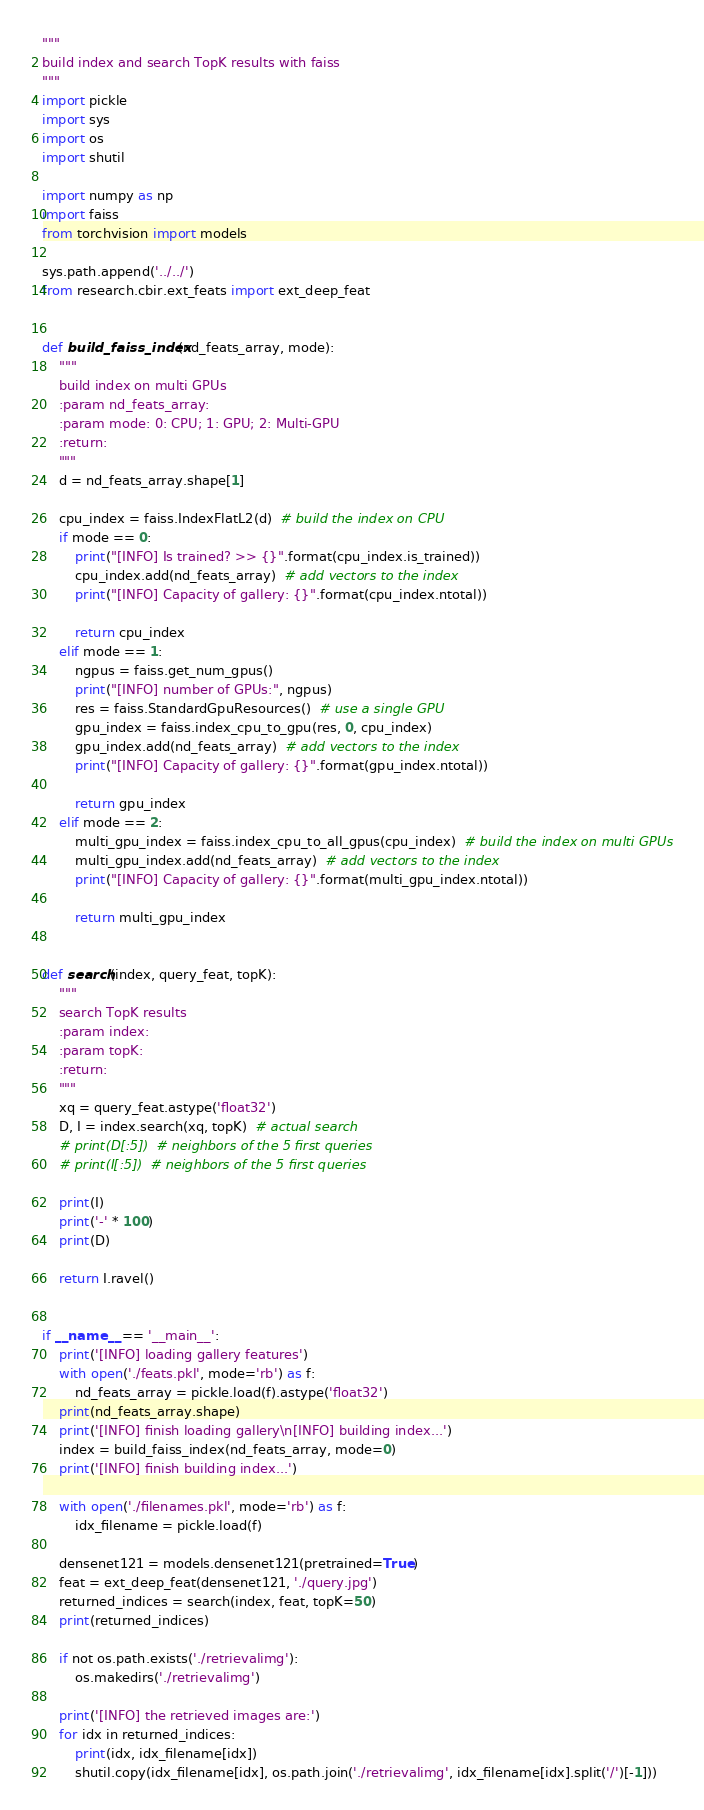Convert code to text. <code><loc_0><loc_0><loc_500><loc_500><_Python_>"""
build index and search TopK results with faiss
"""
import pickle
import sys
import os
import shutil

import numpy as np
import faiss
from torchvision import models

sys.path.append('../../')
from research.cbir.ext_feats import ext_deep_feat


def build_faiss_index(nd_feats_array, mode):
    """
    build index on multi GPUs
    :param nd_feats_array:
    :param mode: 0: CPU; 1: GPU; 2: Multi-GPU
    :return:
    """
    d = nd_feats_array.shape[1]

    cpu_index = faiss.IndexFlatL2(d)  # build the index on CPU
    if mode == 0:
        print("[INFO] Is trained? >> {}".format(cpu_index.is_trained))
        cpu_index.add(nd_feats_array)  # add vectors to the index
        print("[INFO] Capacity of gallery: {}".format(cpu_index.ntotal))

        return cpu_index
    elif mode == 1:
        ngpus = faiss.get_num_gpus()
        print("[INFO] number of GPUs:", ngpus)
        res = faiss.StandardGpuResources()  # use a single GPU
        gpu_index = faiss.index_cpu_to_gpu(res, 0, cpu_index)
        gpu_index.add(nd_feats_array)  # add vectors to the index
        print("[INFO] Capacity of gallery: {}".format(gpu_index.ntotal))

        return gpu_index
    elif mode == 2:
        multi_gpu_index = faiss.index_cpu_to_all_gpus(cpu_index)  # build the index on multi GPUs
        multi_gpu_index.add(nd_feats_array)  # add vectors to the index
        print("[INFO] Capacity of gallery: {}".format(multi_gpu_index.ntotal))

        return multi_gpu_index


def search(index, query_feat, topK):
    """
    search TopK results
    :param index:
    :param topK:
    :return:
    """
    xq = query_feat.astype('float32')
    D, I = index.search(xq, topK)  # actual search
    # print(D[:5])  # neighbors of the 5 first queries
    # print(I[:5])  # neighbors of the 5 first queries

    print(I)
    print('-' * 100)
    print(D)

    return I.ravel()


if __name__ == '__main__':
    print('[INFO] loading gallery features')
    with open('./feats.pkl', mode='rb') as f:
        nd_feats_array = pickle.load(f).astype('float32')
    print(nd_feats_array.shape)
    print('[INFO] finish loading gallery\n[INFO] building index...')
    index = build_faiss_index(nd_feats_array, mode=0)
    print('[INFO] finish building index...')

    with open('./filenames.pkl', mode='rb') as f:
        idx_filename = pickle.load(f)

    densenet121 = models.densenet121(pretrained=True)
    feat = ext_deep_feat(densenet121, './query.jpg')
    returned_indices = search(index, feat, topK=50)
    print(returned_indices)

    if not os.path.exists('./retrievalimg'):
        os.makedirs('./retrievalimg')

    print('[INFO] the retrieved images are:')
    for idx in returned_indices:
        print(idx, idx_filename[idx])
        shutil.copy(idx_filename[idx], os.path.join('./retrievalimg', idx_filename[idx].split('/')[-1]))
</code> 